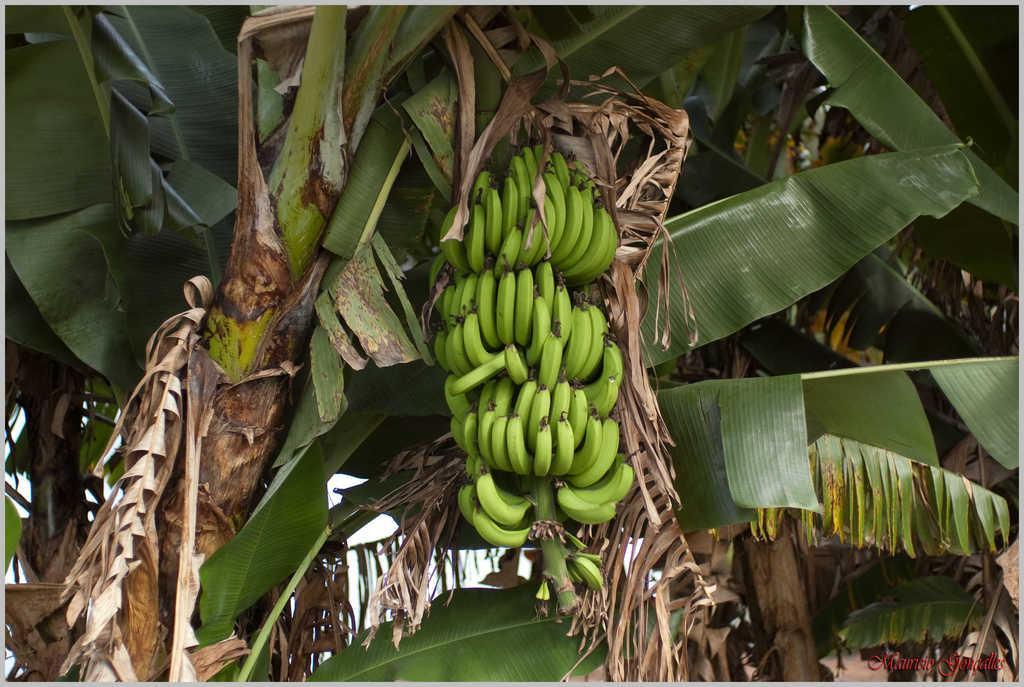How would you summarize this image in a sentence or two? In the image there is a banana plant with bananas to it and behind there are many plants. 